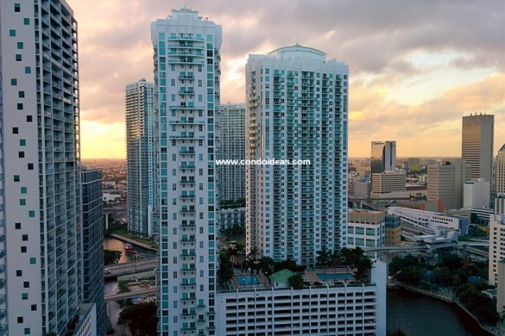Imagine a story based in this urban setting. In a city where the buildings touch the sky, Emma, a young architect, is on the cusp of unveiling her most ambitious project — a skyscraper designed to revolutionize urban living. Her vision is a vertical city encompassing parks, schools, and even open-air markets suspended hundreds of feet above the ground. As she stands on the rooftop of one of these towering structures, watching the sunset paint the city in vibrant hues, she reflects on the day's challenges. Little does she know, her architectural marvel will soon become the epicenter of a city-wide mystery involving missing blueprints, corporate espionage, and a hidden secret that could change the future of urban planning forever. Describe a typical day in the life of someone living in one of these buildings. For John, a young professional living in one of the high-rise apartments, a typical day begins early. He wakes up to the panoramic view of the city bathed in morning light, enjoying his coffee on the balcony as the city slowly wakes up beneath him. After a quick gym session in the building's state-of-the-art fitness center, he heads to his office, just a short walk away. Lunch is often spent at one of the chic cafes nearby, where he meets colleagues. Evenings are reserved for relaxation, either at a rooftop pool or hosting friends in his sleek apartment. The convenience of the urban jungle outside his door is balanced by the tranquility and luxury of his high-rise life. What kind of businesses might be thriving in this area? In this bustling urban center, a variety of businesses could be thriving. Tech startups and financial firms likely dominate the office spaces, taking advantage of the modern infrastructure. High-end retail stores and boutiques offer shopping opportunities for the affluent city dwellers. There are probably numerous restaurants, cafes, and bars serving a wide range of cuisines, catering to the diverse population. Wellness centers, gyms, and spas provide relaxation and fitness options, while cultural venues such as art galleries and theaters enrich the city's vibrant social tapestry. 